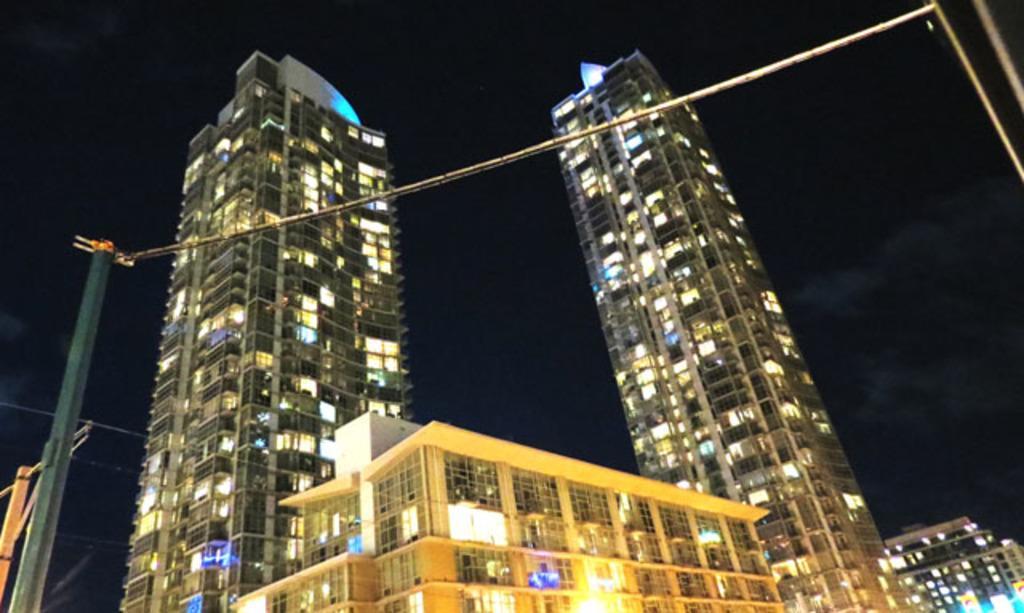Please provide a concise description of this image. In this image I can see few buildings and on the left side of this image I can see few poles. 